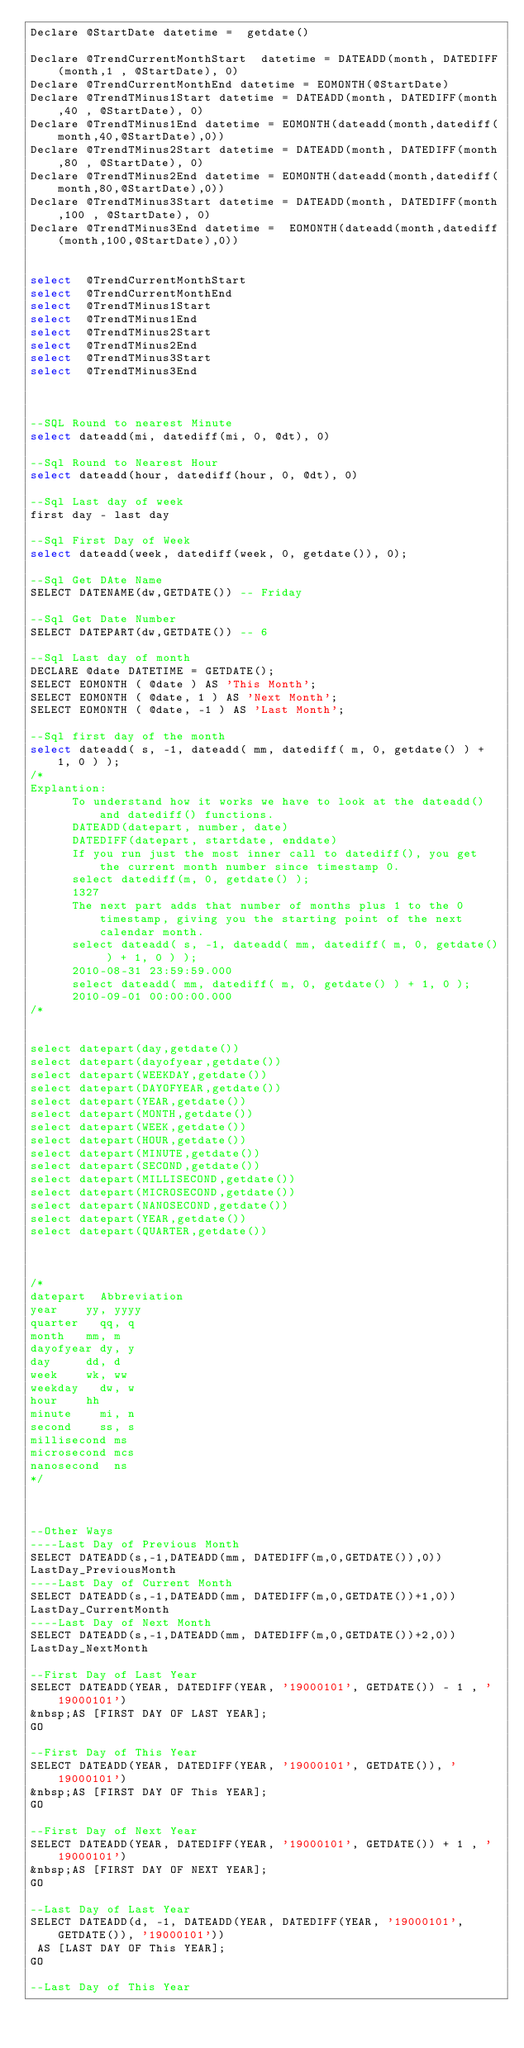<code> <loc_0><loc_0><loc_500><loc_500><_SQL_>Declare @StartDate datetime =  getdate()

Declare @TrendCurrentMonthStart  datetime = DATEADD(month, DATEDIFF(month,1 , @StartDate), 0)
Declare @TrendCurrentMonthEnd datetime = EOMONTH(@StartDate)
Declare @TrendTMinus1Start datetime = DATEADD(month, DATEDIFF(month,40 , @StartDate), 0)
Declare @TrendTMinus1End datetime = EOMONTH(dateadd(month,datediff(month,40,@StartDate),0))
Declare @TrendTMinus2Start datetime = DATEADD(month, DATEDIFF(month,80 , @StartDate), 0)
Declare @TrendTMinus2End datetime = EOMONTH(dateadd(month,datediff(month,80,@StartDate),0))
Declare @TrendTMinus3Start datetime = DATEADD(month, DATEDIFF(month,100 , @StartDate), 0)
Declare @TrendTMinus3End datetime =  EOMONTH(dateadd(month,datediff(month,100,@StartDate),0))


select  @TrendCurrentMonthStart
select  @TrendCurrentMonthEnd  
select  @TrendTMinus1Start 
select  @TrendTMinus1End 
select  @TrendTMinus2Start
select  @TrendTMinus2End 
select  @TrendTMinus3Start 
select  @TrendTMinus3End 



--SQL Round to nearest Minute
select dateadd(mi, datediff(mi, 0, @dt), 0)

--Sql Round to Nearest Hour
select dateadd(hour, datediff(hour, 0, @dt), 0)

--Sql Last day of week
first day - last day

--Sql First Day of Week
select dateadd(week, datediff(week, 0, getdate()), 0);

--Sql Get DAte Name
SELECT DATENAME(dw,GETDATE()) -- Friday

--Sql Get Date Number
SELECT DATEPART(dw,GETDATE()) -- 6

--Sql Last day of month
DECLARE @date DATETIME = GETDATE();  
SELECT EOMONTH ( @date ) AS 'This Month';  
SELECT EOMONTH ( @date, 1 ) AS 'Next Month';  
SELECT EOMONTH ( @date, -1 ) AS 'Last Month';  

--Sql first day of the month
select dateadd( s, -1, dateadd( mm, datediff( m, 0, getdate() ) + 1, 0 ) );
/*
Explantion:
			To understand how it works we have to look at the dateadd() and datediff() functions.
			DATEADD(datepart, number, date)  
			DATEDIFF(datepart, startdate, enddate)
			If you run just the most inner call to datediff(), you get the current month number since timestamp 0.
			select datediff(m, 0, getdate() );  
			1327
			The next part adds that number of months plus 1 to the 0 timestamp, giving you the starting point of the next calendar month.
			select dateadd( s, -1, dateadd( mm, datediff( m, 0, getdate() ) + 1, 0 ) );
			2010-08-31 23:59:59.000	
			select dateadd( mm, datediff( m, 0, getdate() ) + 1, 0 );
			2010-09-01 00:00:00.000
/*

			
select datepart(day,getdate())
select datepart(dayofyear,getdate())
select datepart(WEEKDAY,getdate())
select datepart(DAYOFYEAR,getdate())
select datepart(YEAR,getdate())
select datepart(MONTH,getdate())
select datepart(WEEK,getdate())
select datepart(HOUR,getdate())
select datepart(MINUTE,getdate())
select datepart(SECOND,getdate())
select datepart(MILLISECOND,getdate())
select datepart(MICROSECOND,getdate())
select datepart(NANOSECOND,getdate())
select datepart(YEAR,getdate())
select datepart(QUARTER,getdate())



/*
datepart	Abbreviation
year		yy, yyyy
quarter		qq, q
month		mm, m
dayofyear	dy, y
day			dd, d
week		wk, ww
weekday		dw, w
hour		hh
minute		mi, n
second		ss, s
millisecond	ms
microsecond	mcs
nanosecond	ns
*/



--Other Ways
----Last Day of Previous Month
SELECT DATEADD(s,-1,DATEADD(mm, DATEDIFF(m,0,GETDATE()),0))
LastDay_PreviousMonth
----Last Day of Current Month
SELECT DATEADD(s,-1,DATEADD(mm, DATEDIFF(m,0,GETDATE())+1,0))
LastDay_CurrentMonth
----Last Day of Next Month
SELECT DATEADD(s,-1,DATEADD(mm, DATEDIFF(m,0,GETDATE())+2,0))
LastDay_NextMonth

--First Day of Last Year
SELECT DATEADD(YEAR, DATEDIFF(YEAR, '19000101', GETDATE()) - 1 , '19000101')
&nbsp;AS [FIRST DAY OF LAST YEAR];
GO

--First Day of This Year
SELECT DATEADD(YEAR, DATEDIFF(YEAR, '19000101', GETDATE()), '19000101')
&nbsp;AS [FIRST DAY OF This YEAR];
GO

--First Day of Next Year
SELECT DATEADD(YEAR, DATEDIFF(YEAR, '19000101', GETDATE()) + 1 , '19000101')
&nbsp;AS [FIRST DAY OF NEXT YEAR];
GO

--Last Day of Last Year
SELECT DATEADD(d, -1, DATEADD(YEAR, DATEDIFF(YEAR, '19000101', GETDATE()), '19000101'))
 AS [LAST DAY OF This YEAR];
GO

--Last Day of This Year</code> 